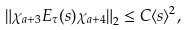Convert formula to latex. <formula><loc_0><loc_0><loc_500><loc_500>\left \| \chi _ { a + 3 } E _ { \tau } ( s ) \chi _ { a + 4 } \right \| _ { 2 } \leq C \langle s \rangle ^ { 2 } ,</formula> 